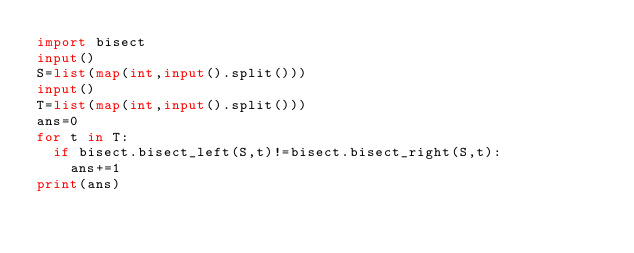<code> <loc_0><loc_0><loc_500><loc_500><_Python_>import bisect 
input()
S=list(map(int,input().split()))
input()
T=list(map(int,input().split()))
ans=0
for t in T:
  if bisect.bisect_left(S,t)!=bisect.bisect_right(S,t):
    ans+=1
print(ans)
</code> 